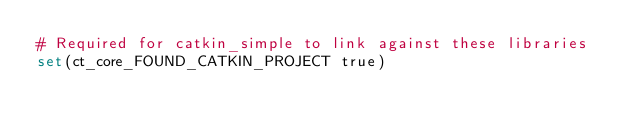<code> <loc_0><loc_0><loc_500><loc_500><_CMake_># Required for catkin_simple to link against these libraries
set(ct_core_FOUND_CATKIN_PROJECT true)

</code> 